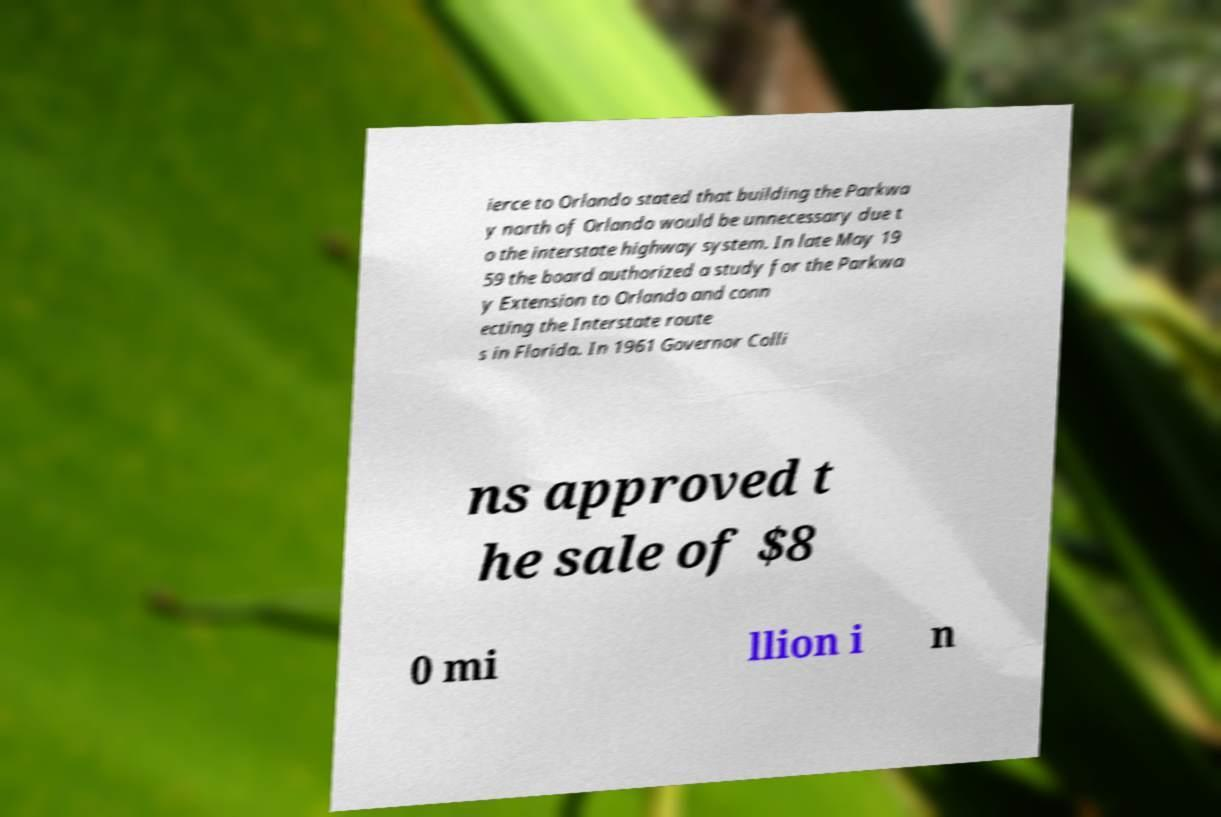Can you read and provide the text displayed in the image?This photo seems to have some interesting text. Can you extract and type it out for me? ierce to Orlando stated that building the Parkwa y north of Orlando would be unnecessary due t o the interstate highway system. In late May 19 59 the board authorized a study for the Parkwa y Extension to Orlando and conn ecting the Interstate route s in Florida. In 1961 Governor Colli ns approved t he sale of $8 0 mi llion i n 